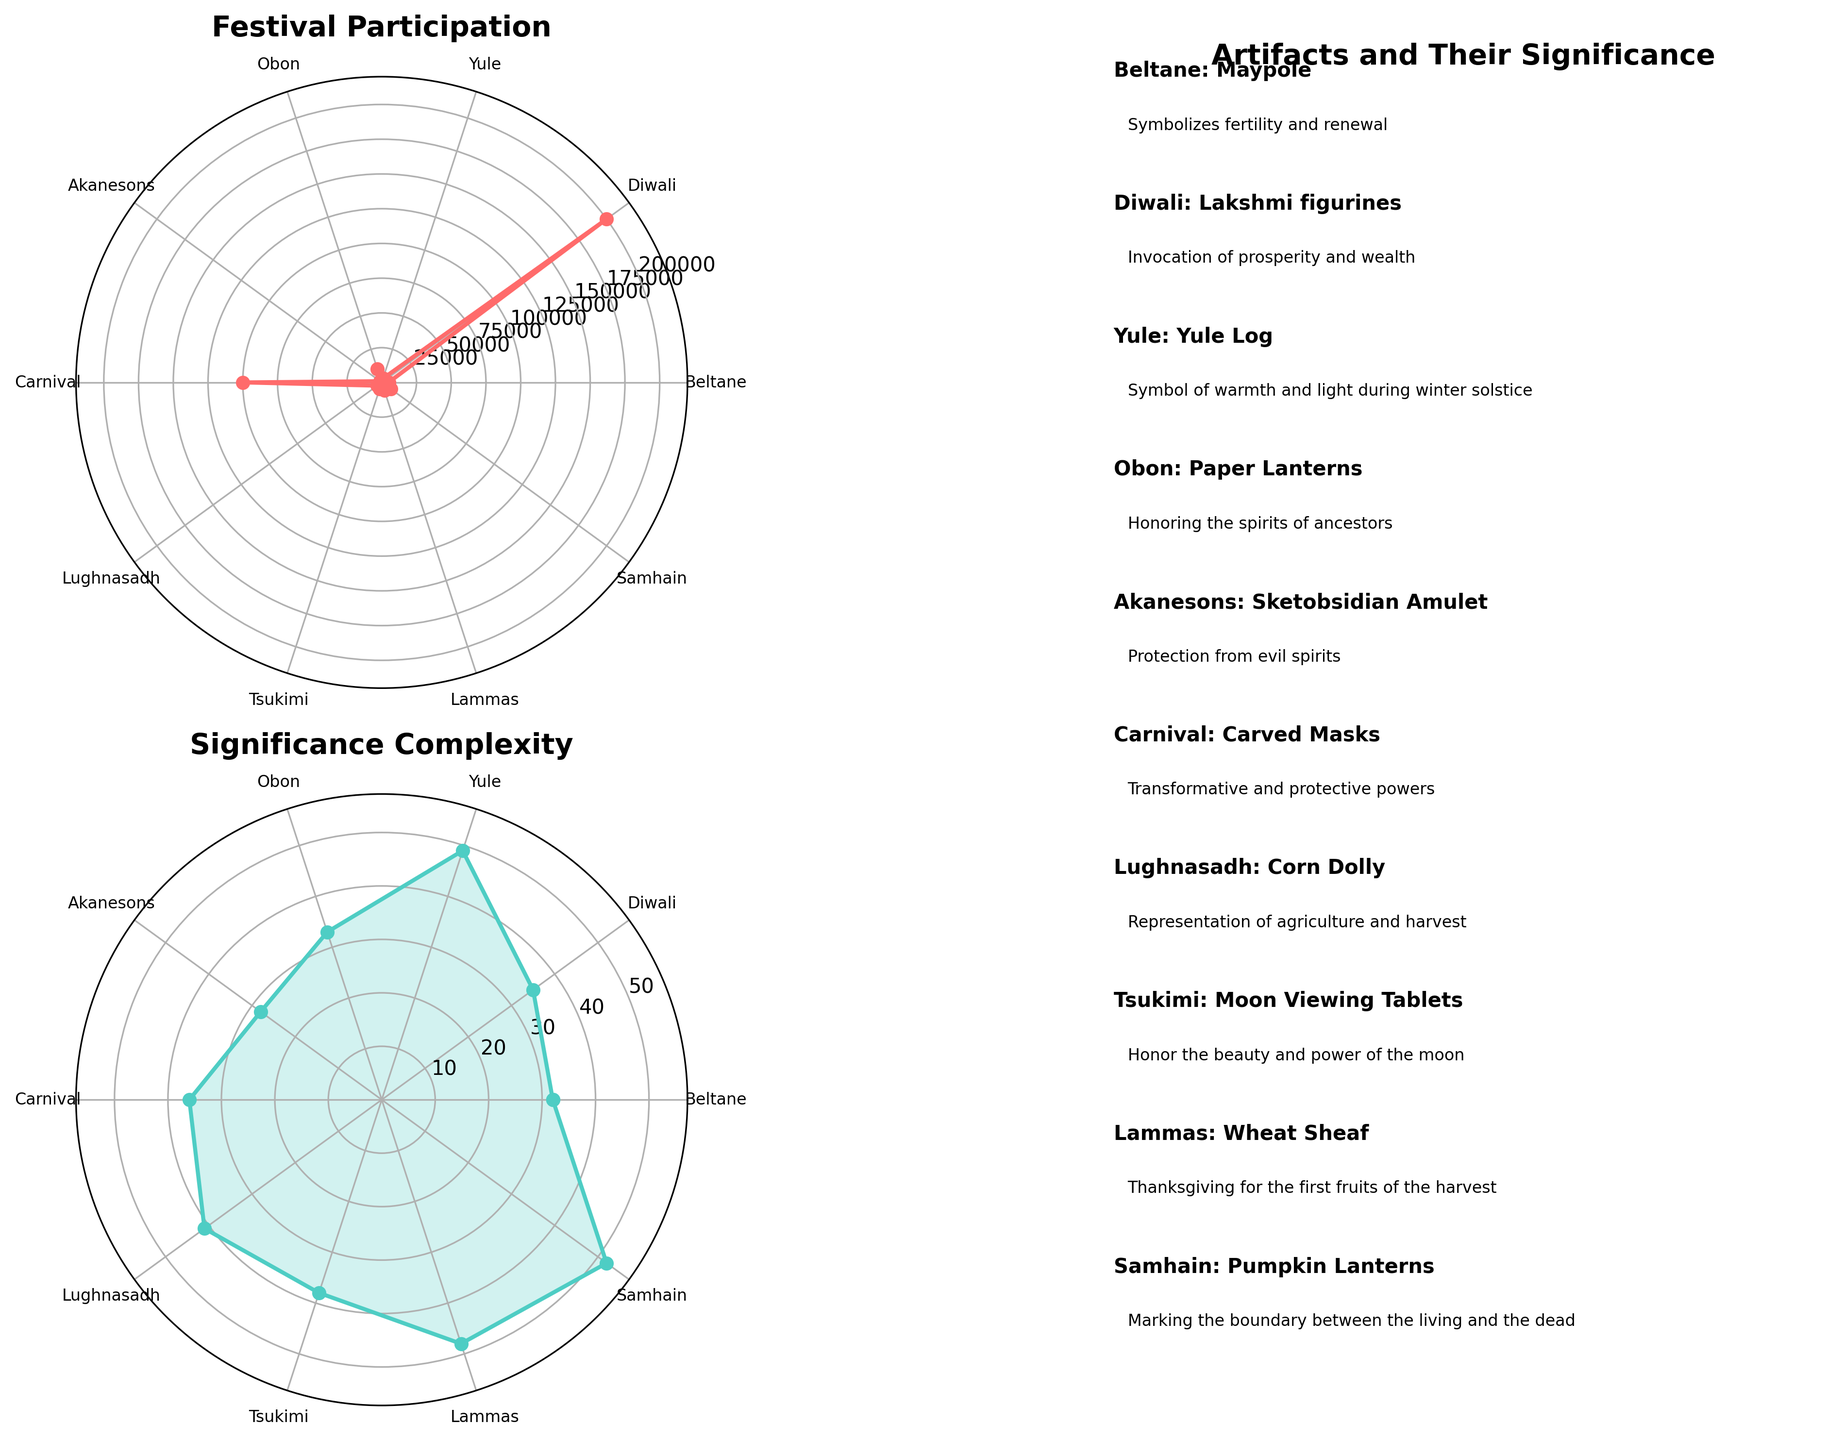How many festivals are shown in the plot? Count the number of distinct festivals listed in the plot.
Answer: 10 What is the title of the first subplot? The title is generally displayed at the top of the subplot. For the first one, it can be seen clearly.
Answer: Festival Participation Which festival has the highest participant count? Observe the highest point in the first polar subplot, then match it with the festival name.
Answer: Diwali What is the significance complexity score of Obon? Examine the second polar subplot and locate the corresponding score for Obon.
Answer: Corresponds to the length of the significance text, which is Honoring the spirits of ancestors. The length is 32 How many festivals are associated with artifacts symbolizing protection? Examine the third subplot for descriptions and tally the festivals with artifacts that provide protection.
Answer: 2 (Akanesons and Carnival) Which region hosts the most festivals depicted in the chart? Scan through the artifact descriptions in the third subplot and tally the region mentions, then find the most frequent one.
Answer: Celtic Nations What is the difference in participant count between the festival with the highest participation and the festival with the lowest? Find the highest and lowest participant counts and compute the difference, which is 200000 - 1500.
Answer: 198500 Which festival has the most complex significance according to the length of the description? Identify the one with the longest description in the second polar subplot. The lengths are: (Maypole: 30), (Lakshmi figurines: 34), (Yule Log: 37), (Paper Lanterns: 34), (Sketobsidian Amulet: 28), (Carved Masks: 34), (Corn Dolly: 35), (Moon Viewing Tablets: 27), (Wheat Sheaf: 37), (Pumpkin Lanterns: 38).
Answer: Pumpkin Lanterns Is there an artifact related to the moon in the festivals shown? Look at the artifact descriptions in the third subplot to identify any mentions of the moon.
Answer: Yes, Tsukimi - Moon Viewing Tablets 